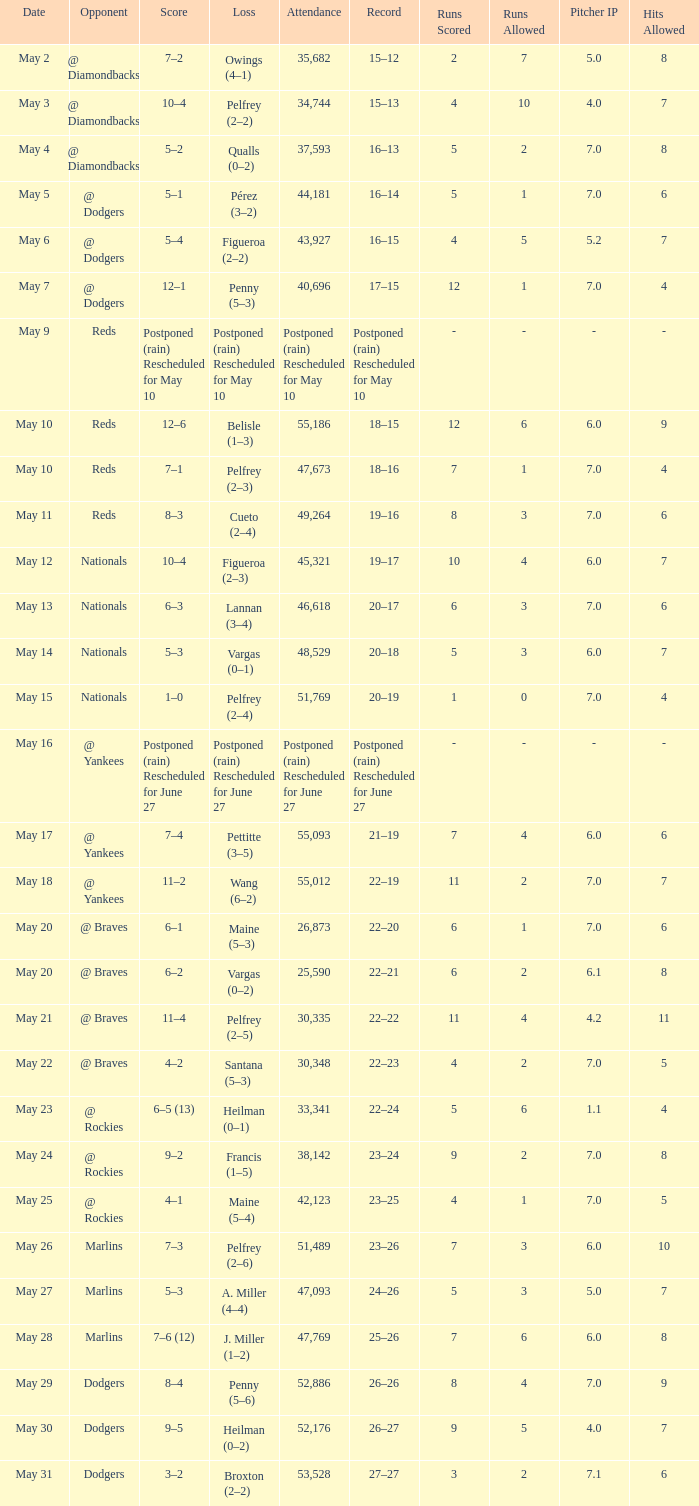Loss of postponed (rain) rescheduled for may 10 had what record? Postponed (rain) Rescheduled for May 10. 